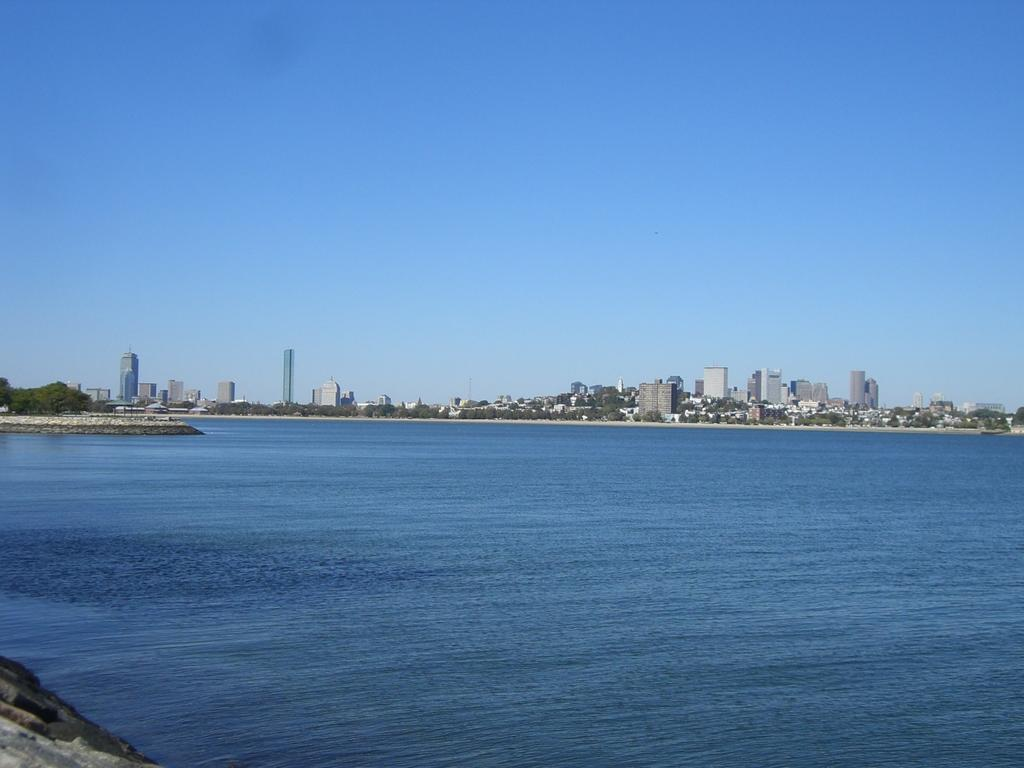What is the main feature in the foreground of the image? There is a water body in the image. What can be seen in the distance behind the water body? There are buildings and trees in the background of the image. How would you describe the sky in the image? The sky is clear in the image. How many police officers are patrolling the water body in the image? There are no police officers present in the image. What type of scarecrow can be seen standing among the trees in the image? There is no scarecrow present in the image; it features a water body, buildings, trees, and a clear sky. 